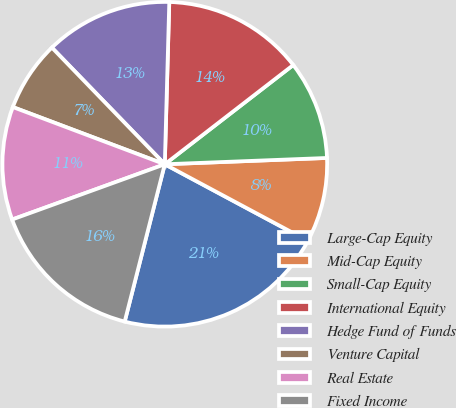Convert chart. <chart><loc_0><loc_0><loc_500><loc_500><pie_chart><fcel>Large-Cap Equity<fcel>Mid-Cap Equity<fcel>Small-Cap Equity<fcel>International Equity<fcel>Hedge Fund of Funds<fcel>Venture Capital<fcel>Real Estate<fcel>Fixed Income<nl><fcel>21.15%<fcel>8.44%<fcel>9.85%<fcel>14.09%<fcel>12.68%<fcel>7.03%<fcel>11.26%<fcel>15.5%<nl></chart> 